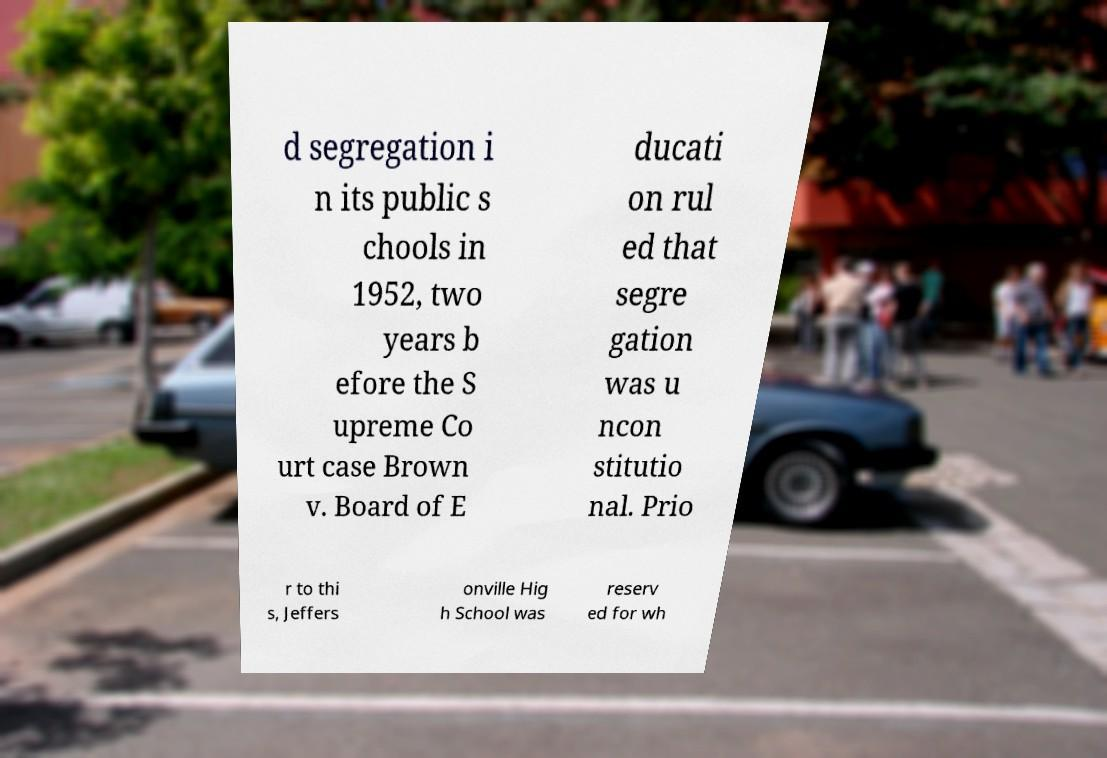Could you extract and type out the text from this image? d segregation i n its public s chools in 1952, two years b efore the S upreme Co urt case Brown v. Board of E ducati on rul ed that segre gation was u ncon stitutio nal. Prio r to thi s, Jeffers onville Hig h School was reserv ed for wh 